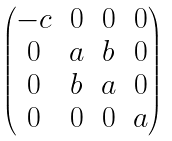Convert formula to latex. <formula><loc_0><loc_0><loc_500><loc_500>\begin{pmatrix} - c & 0 & 0 & 0 \\ 0 & a & b & 0 \\ 0 & b & a & 0 \\ 0 & 0 & 0 & a \end{pmatrix}</formula> 